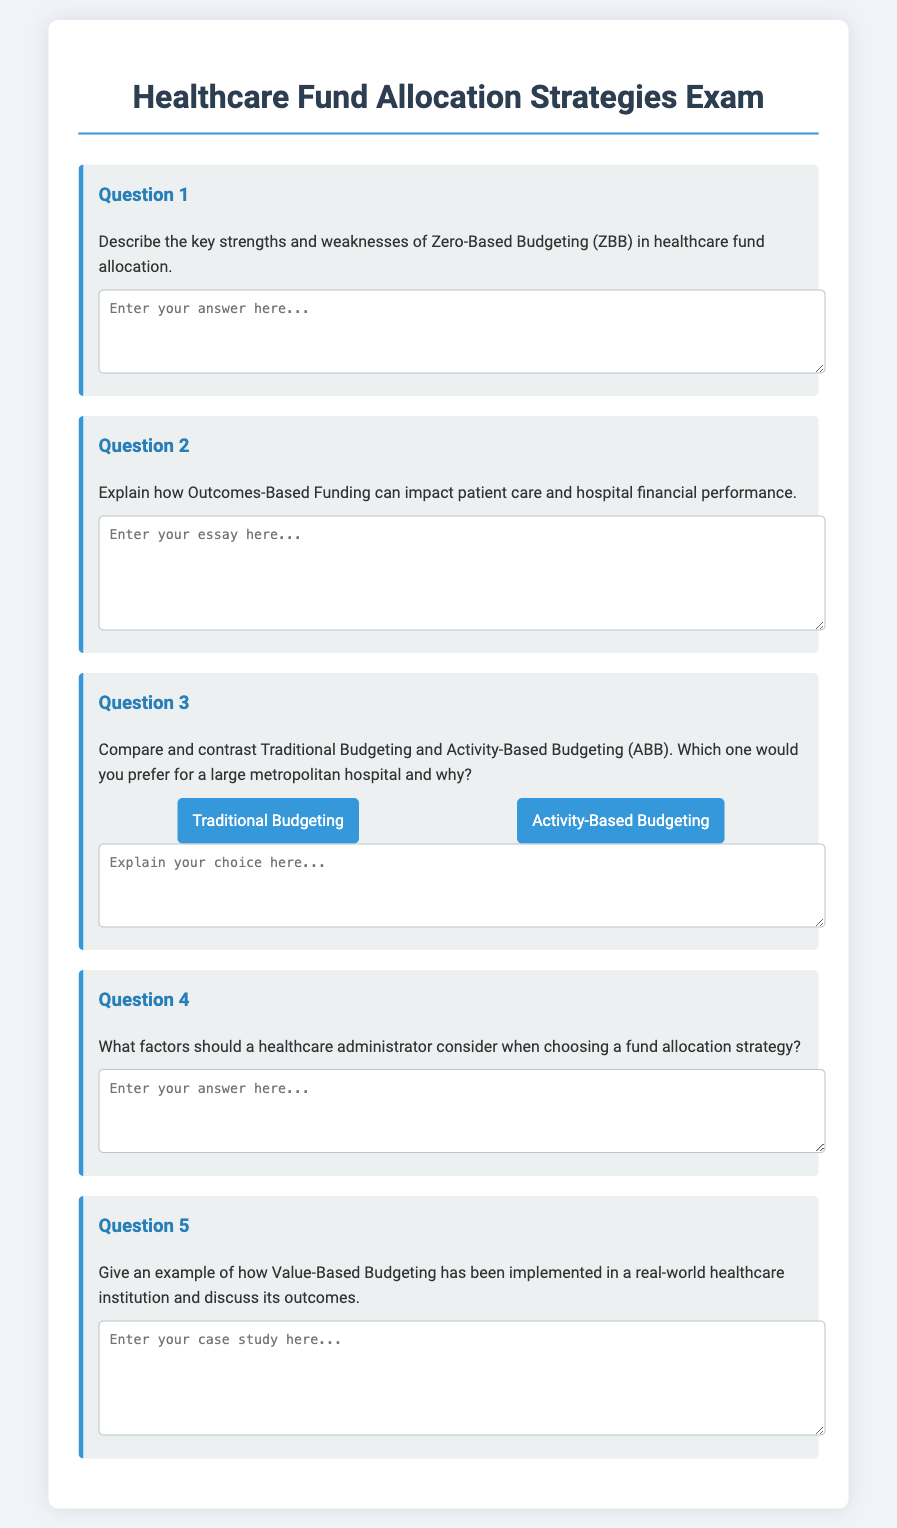What is the title of the document? The title is found in the `<title>` tag of the HTML document, indicating its focus on healthcare fund allocation strategies.
Answer: Healthcare Fund Allocation Strategies Exam What is the maximum width of the exam container? The maximum width of the exam container is specified in the CSS styles for the body and is set to 800 pixels.
Answer: 800px How many questions are included in the exam? The number of questions can be counted from the document structure; there are five distinct questions presented.
Answer: 5 Which budget strategy is mentioned as being implemented in a real-world healthcare institution? The specific budget strategy is referenced in the prompt for Question 5 of the exam.
Answer: Value-Based Budgeting What factors should a healthcare administrator consider according to Question 4? Question 4 asks for various considerations, but does not list them explicitly in the text of the document.
Answer: Factors (specifics not given) What is the background color of the body in the document? The background color is defined in the CSS styles applied to the body of the document.
Answer: #f0f4f8 What is the color of the heading in the document? The color of the heading is specified in the CSS styles under the `h1` selector.
Answer: #2c3e50 Which type of budgeting is preferred for a large metropolitan hospital according to the options in Question 3? The options provided in Question 3 allow the respondent to choose between two budgeting types.
Answer: Traditional Budgeting or Activity-Based Budgeting (choice-dependent) 